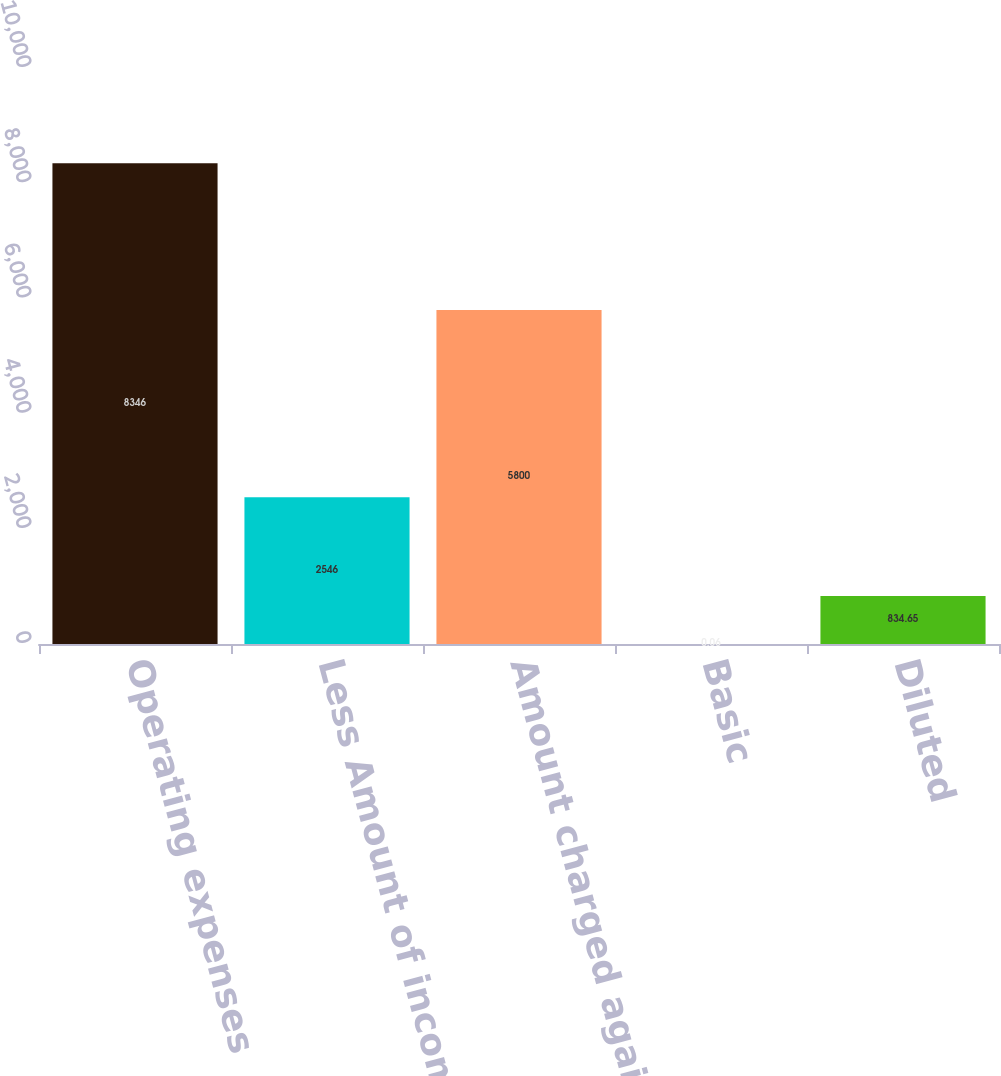Convert chart. <chart><loc_0><loc_0><loc_500><loc_500><bar_chart><fcel>Operating expenses<fcel>Less Amount of income tax<fcel>Amount charged against net<fcel>Basic<fcel>Diluted<nl><fcel>8346<fcel>2546<fcel>5800<fcel>0.06<fcel>834.65<nl></chart> 